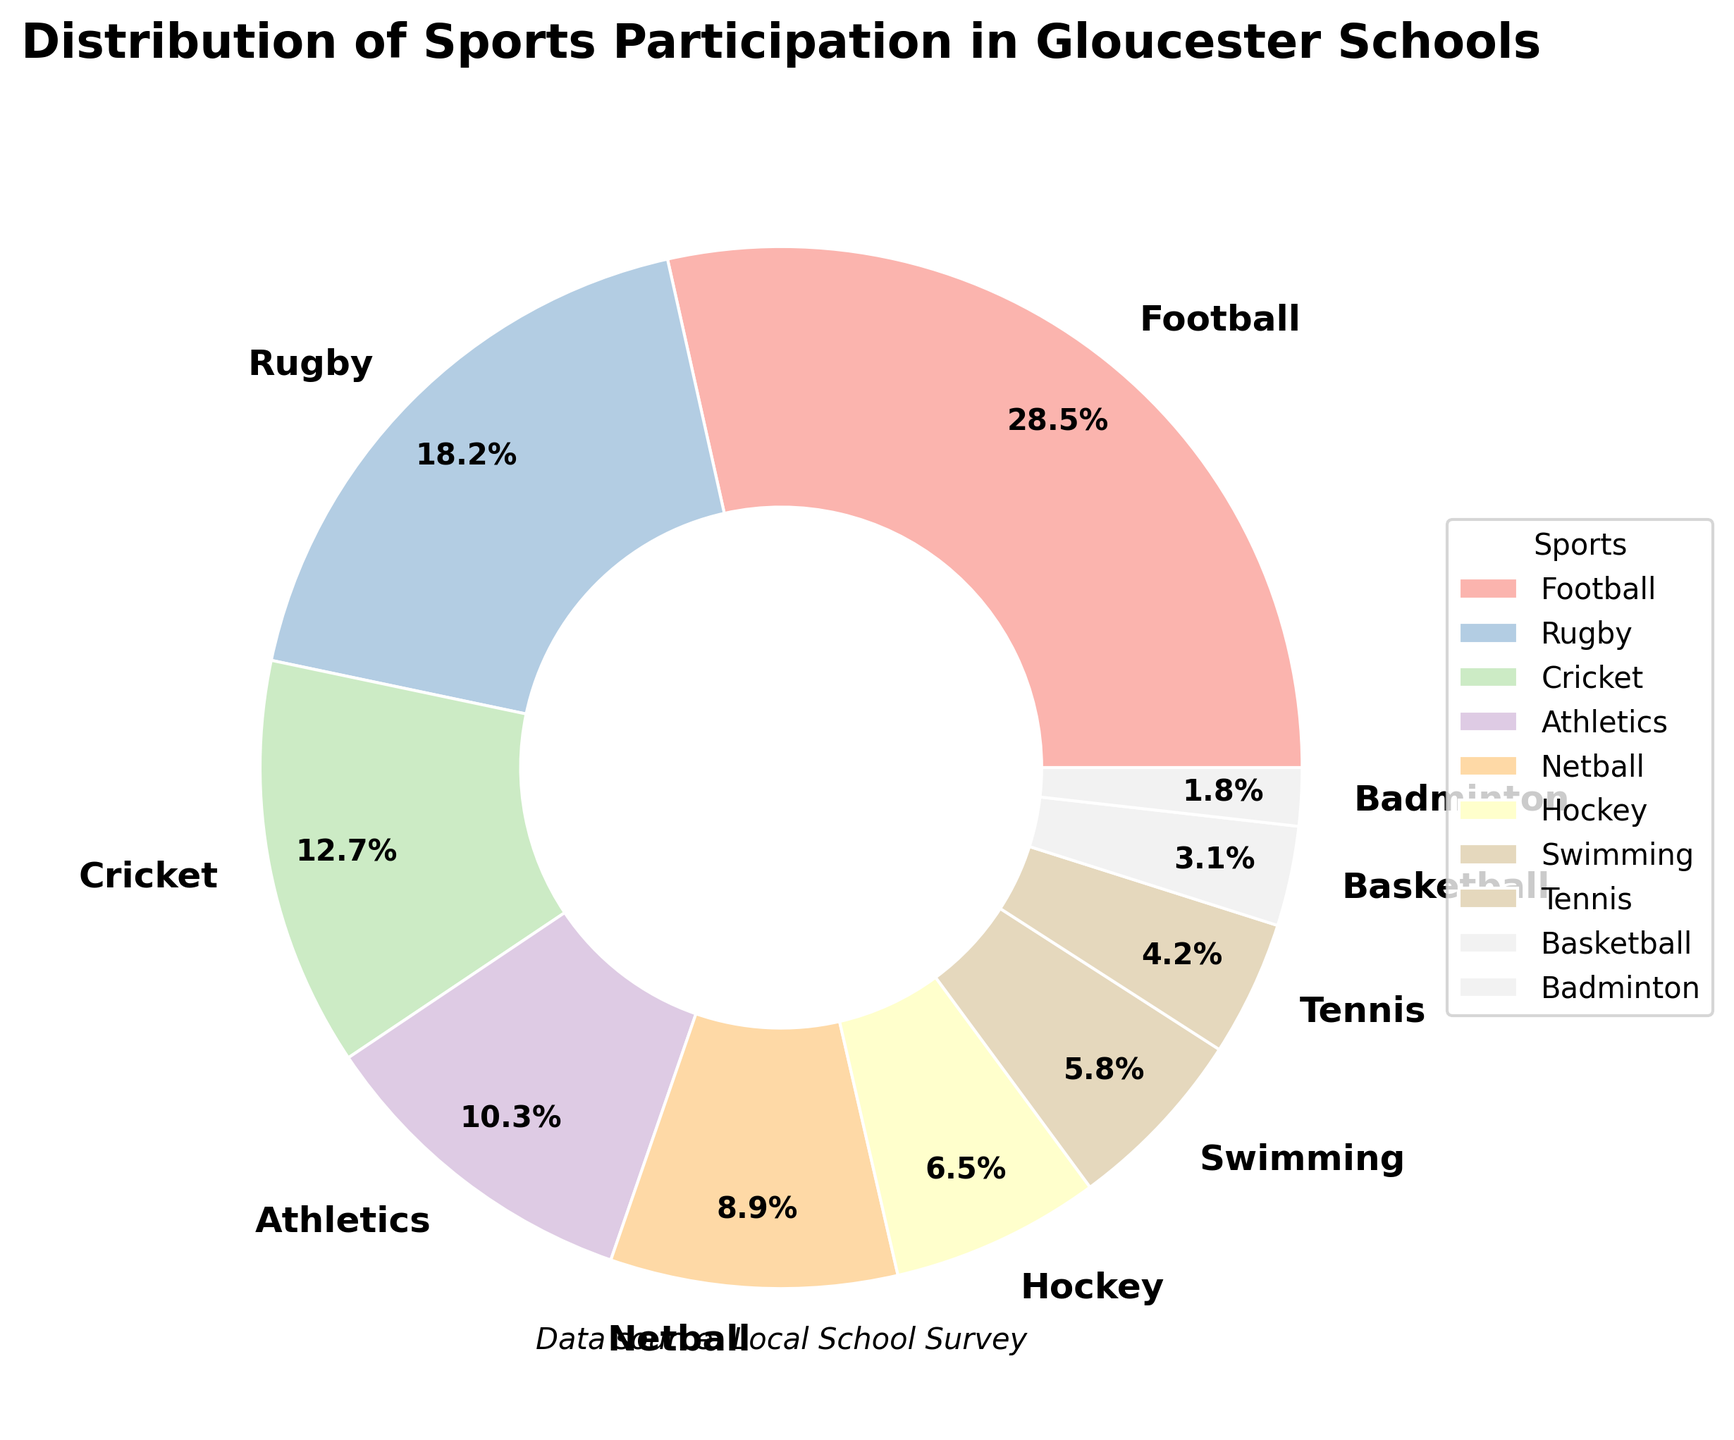Which sport has the highest participation rate? The figure shows a pie chart with slices labeled for different sports. The largest slice, labeled "Football," represents 28.5%, which is the highest participation rate.
Answer: Football What percentage of students participate in Athletics and Netball combined? Identify the slices for Athletics and Netball. Athletics is 10.3% and Netball is 8.9%. Add these percentages together: 10.3% + 8.9% = 19.2%.
Answer: 19.2% Which sport has a higher participation rate, Rugby or Cricket? Compare the slices labeled Rugby and Cricket. Rugby's slice represents 18.2% while Cricket's is 12.7%. Since 18.2% > 12.7%, Rugby has a higher participation rate.
Answer: Rugby Is the participation rate for Swimming higher than for Tennis? Locate the slices for Swimming and Tennis. Swimming represents 5.8% and Tennis represents 4.2%. Since 5.8% > 4.2%, Swimming has a higher participation rate than Tennis.
Answer: Yes What's the combined participation rate of the three least popular sports? Identify the slices with the lowest percentages: Badminton (1.8%), Basketball (3.1%), and Tennis (4.2%). Add these percentages together: 1.8% + 3.1% + 4.2% = 9.1%.
Answer: 9.1% What is the difference in participation rate between the most popular and the least popular sport? The most popular sport, Football, has 28.5% participation, and the least popular sport, Badminton, has 1.8%. Subtract the smallest percentage from the largest: 28.5% - 1.8% = 26.7%.
Answer: 26.7% Are there more students participating in Netball than in Hockey? Compare the slices labeled Netball and Hockey. Netball represents 8.9% and Hockey represents 6.5%. Since 8.9% > 6.5%, more students participate in Netball.
Answer: Yes What is the total participation percentage for the four most popular sports? Identify the top four slices by percentage: Football (28.5%), Rugby (18.2%), Cricket (12.7%), and Athletics (10.3%). Add these percentages together: 28.5% + 18.2% + 12.7% + 10.3% = 69.7%.
Answer: 69.7% Does the participation in Hockey exceed the total participation in Basketball and Badminton combined? Identify the slices for Hockey (6.5%), Basketball (3.1%), and Badminton (1.8%). Add Basketball and Badminton's percentages: 3.1% + 1.8% = 4.9%. Compare with Hockey's 6.5%. Since 6.5% > 4.9%, Hockey's participation exceeds the combined total of Basketball and Badminton.
Answer: Yes 